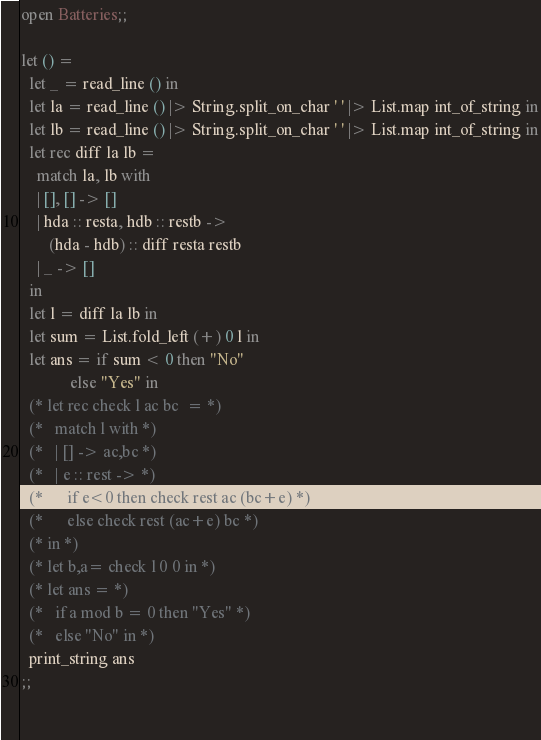Convert code to text. <code><loc_0><loc_0><loc_500><loc_500><_OCaml_>open Batteries;;
  
let () =
  let _ = read_line () in
  let la = read_line () |> String.split_on_char ' ' |> List.map int_of_string in
  let lb = read_line () |> String.split_on_char ' ' |> List.map int_of_string in
  let rec diff la lb =
    match la, lb with
    | [], [] -> []
    | hda :: resta, hdb :: restb ->
       (hda - hdb) :: diff resta restb
    | _ -> []
  in
  let l = diff la lb in
  let sum = List.fold_left (+) 0 l in
  let ans = if sum < 0 then "No"
            else "Yes" in
  (* let rec check l ac bc  = *)
  (*   match l with *)
  (*   | [] -> ac,bc *)
  (*   | e :: rest -> *)
  (*      if e<0 then check rest ac (bc+e) *)
  (*      else check rest (ac+e) bc *)
  (* in *)
  (* let b,a= check l 0 0 in *)
  (* let ans = *)
  (*   if a mod b = 0 then "Yes" *)
  (*   else "No" in *)
  print_string ans
;;
        
  </code> 